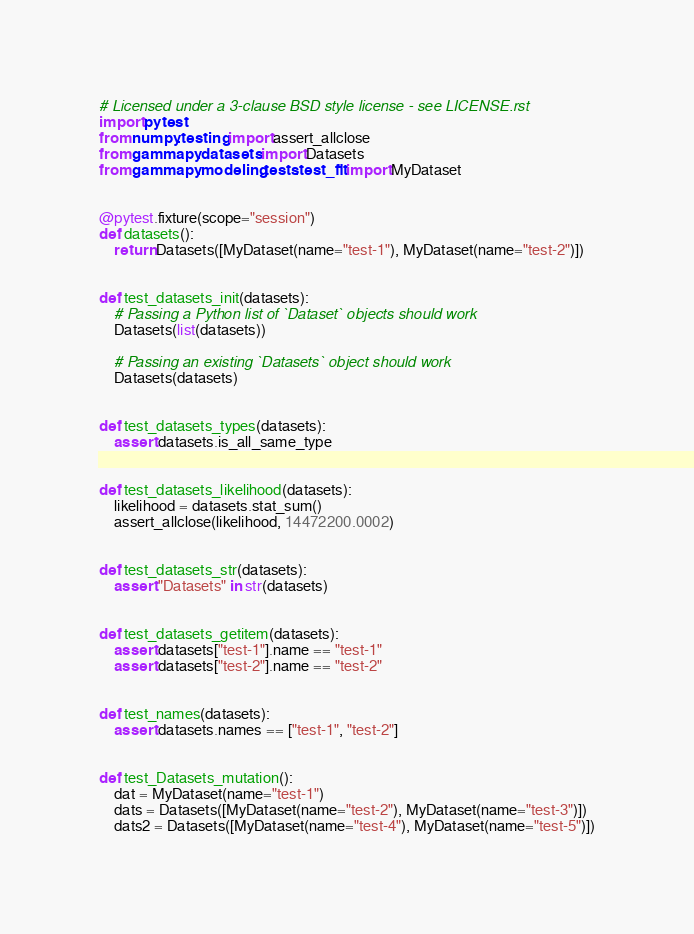<code> <loc_0><loc_0><loc_500><loc_500><_Python_># Licensed under a 3-clause BSD style license - see LICENSE.rst
import pytest
from numpy.testing import assert_allclose
from gammapy.datasets import Datasets
from gammapy.modeling.tests.test_fit import MyDataset


@pytest.fixture(scope="session")
def datasets():
    return Datasets([MyDataset(name="test-1"), MyDataset(name="test-2")])


def test_datasets_init(datasets):
    # Passing a Python list of `Dataset` objects should work
    Datasets(list(datasets))

    # Passing an existing `Datasets` object should work
    Datasets(datasets)


def test_datasets_types(datasets):
    assert datasets.is_all_same_type


def test_datasets_likelihood(datasets):
    likelihood = datasets.stat_sum()
    assert_allclose(likelihood, 14472200.0002)


def test_datasets_str(datasets):
    assert "Datasets" in str(datasets)


def test_datasets_getitem(datasets):
    assert datasets["test-1"].name == "test-1"
    assert datasets["test-2"].name == "test-2"


def test_names(datasets):
    assert datasets.names == ["test-1", "test-2"]


def test_Datasets_mutation():
    dat = MyDataset(name="test-1")
    dats = Datasets([MyDataset(name="test-2"), MyDataset(name="test-3")])
    dats2 = Datasets([MyDataset(name="test-4"), MyDataset(name="test-5")])
</code> 